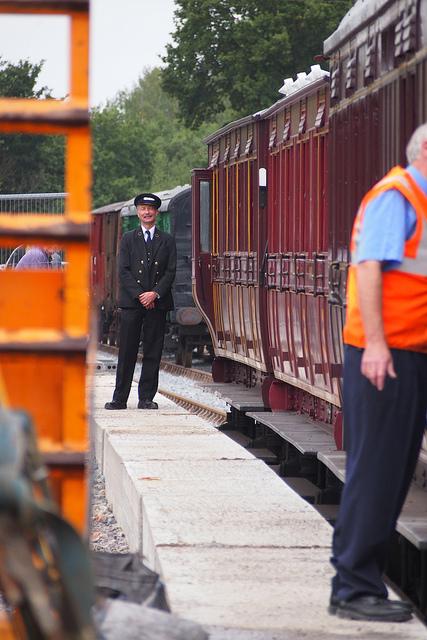IS the man in the background wearing a black tie?
Give a very brief answer. Yes. What color is the man's vest?
Give a very brief answer. Orange. Is this near a train track?
Write a very short answer. Yes. 